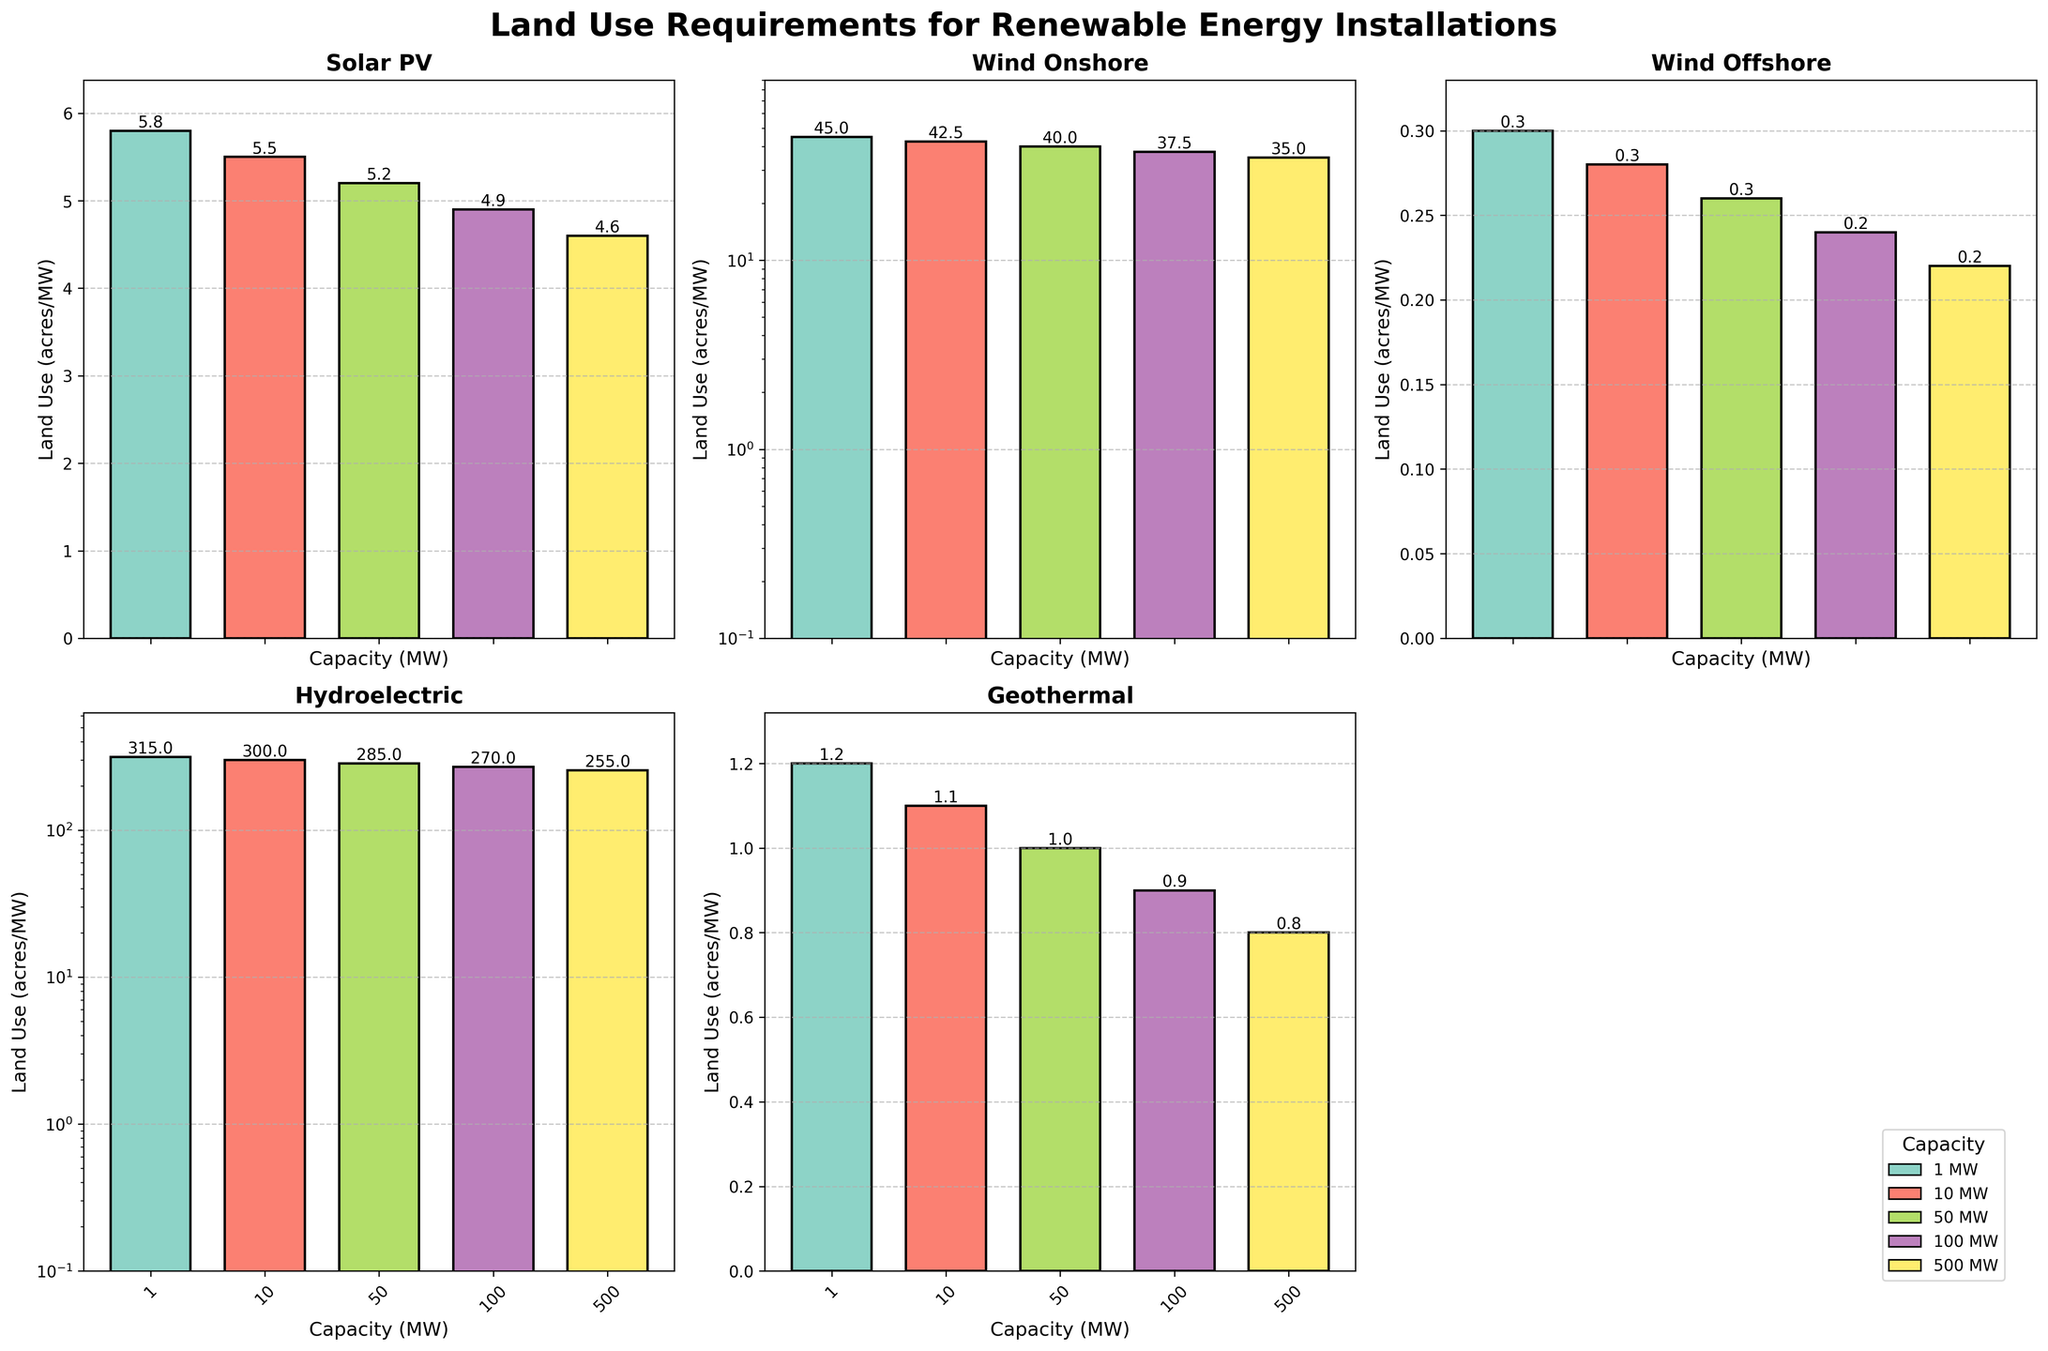Which technology has the highest land use requirement for a 1 MW capacity? From the figure, the bar representing 1 MW capacity for Hydroelectric technology is the tallest, indicating the highest land use in acres/MW.
Answer: Hydroelectric Among Solar PV and Onshore Wind, which technology shows a more significant decrease in land use requirement as the capacity increases from 1 MW to 500 MW? Solar PV's bars decrease from 5.8 acres/MW to 4.6 acres/MW, while Onshore Wind's bars decrease from 45.0 acres/MW to 35.0 acres/MW. The decrease is more significant in absolute terms for Onshore Wind.
Answer: Onshore Wind For which capacities does Geothermal technology require less land than Biomass? By comparing the height of bars for Geothermal and Biomass at each capacity, Geothermal has shorter (lower land use) bars at all capacities (1 MW, 10 MW, 50 MW, 100 MW, 500 MW).
Answer: All capacities If a project requires 50 MW capacity, which technology would involve the least land use and what would it be? From the figure, Wind Offshore technology has the shortest bar for 50 MW capacity, indicating the least land use. The value is 0.26 acres/MW.
Answer: Wind Offshore, 0.26 acres/MW What is the difference in land use requirement between Hydroelectric and Solar PV technologies at 100 MW capacity? The bar for Hydroelectric at 100 MW capacity shows 270 acres/MW, and the bar for Solar PV shows 4.9 acres/MW. The difference is 270 - 4.9 = 265.1 acres/MW.
Answer: 265.1 acres/MW What is the median land use value for Wind Onshore technology across all capacities? The land use values for Wind Onshore are 45.0, 42.5, 40.0, 37.5, and 35.0 acres/MW, arranged in ascending order 35.0, 37.5, 40.0, 42.5, 45.0. The median value is the middle value, which is 40.0 acres/MW.
Answer: 40.0 acres/MW Which technology's land use requirement sees the least amount of change between 1 MW and 500 MW capacities? Comparing the height difference between 1 MW and 500 MW bars for all technologies, Wind Offshore shows a slight change from 0.3 to 0.22 acres/MW.
Answer: Wind Offshore Does any technology show a consistent decrease in land use per MW as capacity increases? Technologies with consistently decreasing bar heights across increasing capacities include Solar PV, Onshore Wind, Offshore Wind, and Hydroelectric.
Answer: Yes Which technology uses more land for a 500 MW capacity: Biomass or Geothermal? The 500 MW capacity bar for Biomass is higher than that for Geothermal. Specifically, Biomass requires 5.3 acres/MW, whereas Geothermal requires 0.8 acres/MW.
Answer: Biomass In terms of visual height, which technology's bars undergo a logarithmic scale adjustment for better visualization? Technologies with large variations in land use requirements (e.g., Wind Onshore and Hydroelectric) use a logarithmic scale for the vertical axis, as indicated by their broad range and the log scaling symbol (log scale).
Answer: Wind Onshore and Hydroelectric 